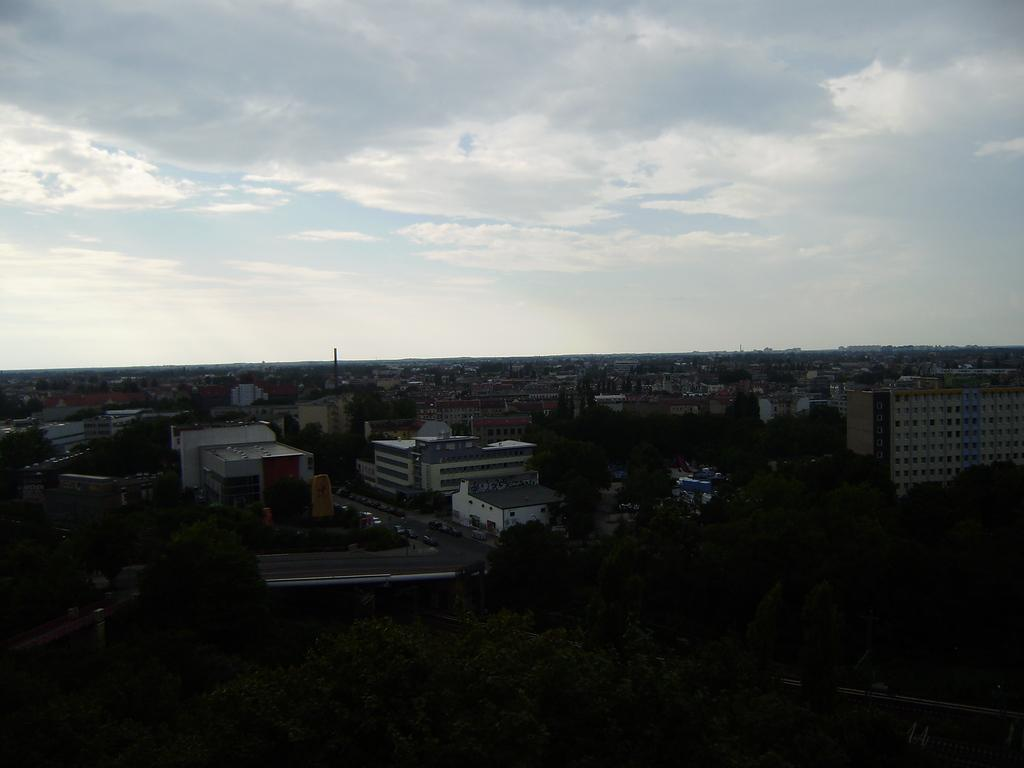What type of view is provided in the image? The image is an aerial view of a particular area. What natural elements can be seen in the area? There are trees in the area. What man-made structures are present in the area? There are roads, vehicles, and buildings in the area. What is visible at the top of the image? The sky is clear at the top of the image. What type of cart is being pulled by a ray in the image? There is no cart or ray present in the image. 